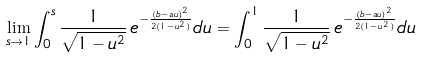Convert formula to latex. <formula><loc_0><loc_0><loc_500><loc_500>\lim _ { s \to 1 } \int _ { 0 } ^ { s } \frac { 1 } { \sqrt { 1 - u ^ { 2 } } } \, e ^ { - \frac { ( b - a u ) ^ { 2 } } { 2 ( 1 - u ^ { 2 } ) } } d u = \int _ { 0 } ^ { 1 } \frac { 1 } { \sqrt { 1 - u ^ { 2 } } } \, e ^ { - \frac { ( b - a u ) ^ { 2 } } { 2 ( 1 - u ^ { 2 } ) } } d u</formula> 